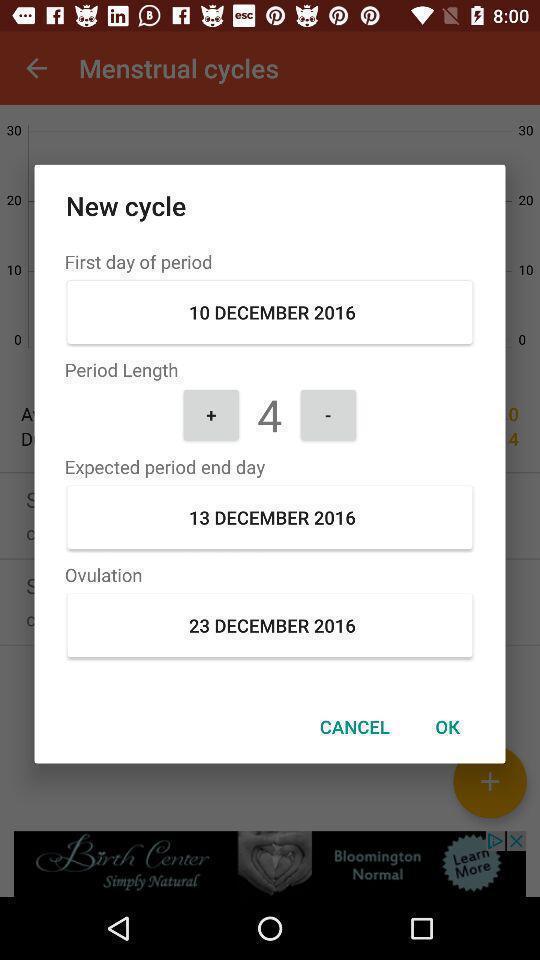What can you discern from this picture? Pop-up window displaying period tracking details. 